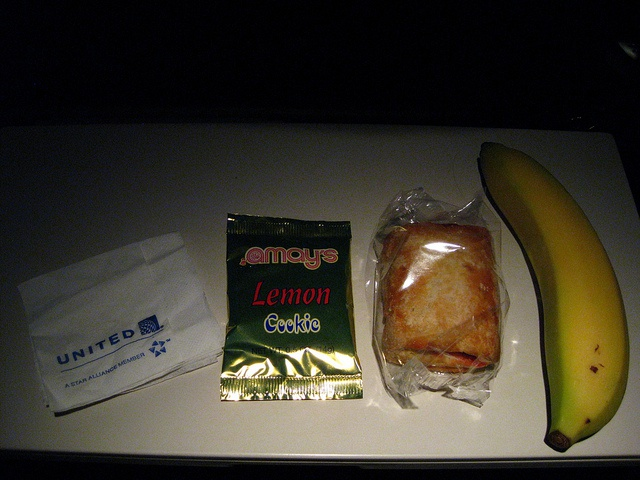Describe the objects in this image and their specific colors. I can see banana in black and olive tones and sandwich in black, maroon, olive, and gray tones in this image. 